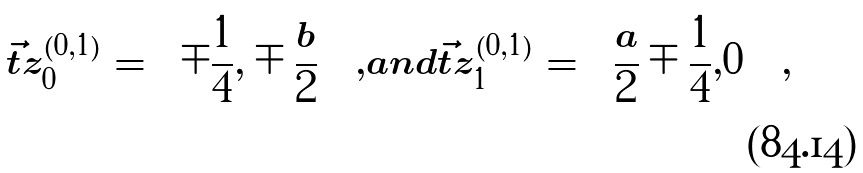<formula> <loc_0><loc_0><loc_500><loc_500>\vec { t } { z } _ { 0 } ^ { ( 0 , 1 ) } = \left ( \mp \frac { 1 } { 4 } , \mp \frac { b } { 2 } \right ) \, , a n d \vec { t } { z } _ { 1 } ^ { ( 0 , 1 ) } = \left ( \frac { a } { 2 } \mp \frac { 1 } { 4 } , 0 \right ) \, ,</formula> 